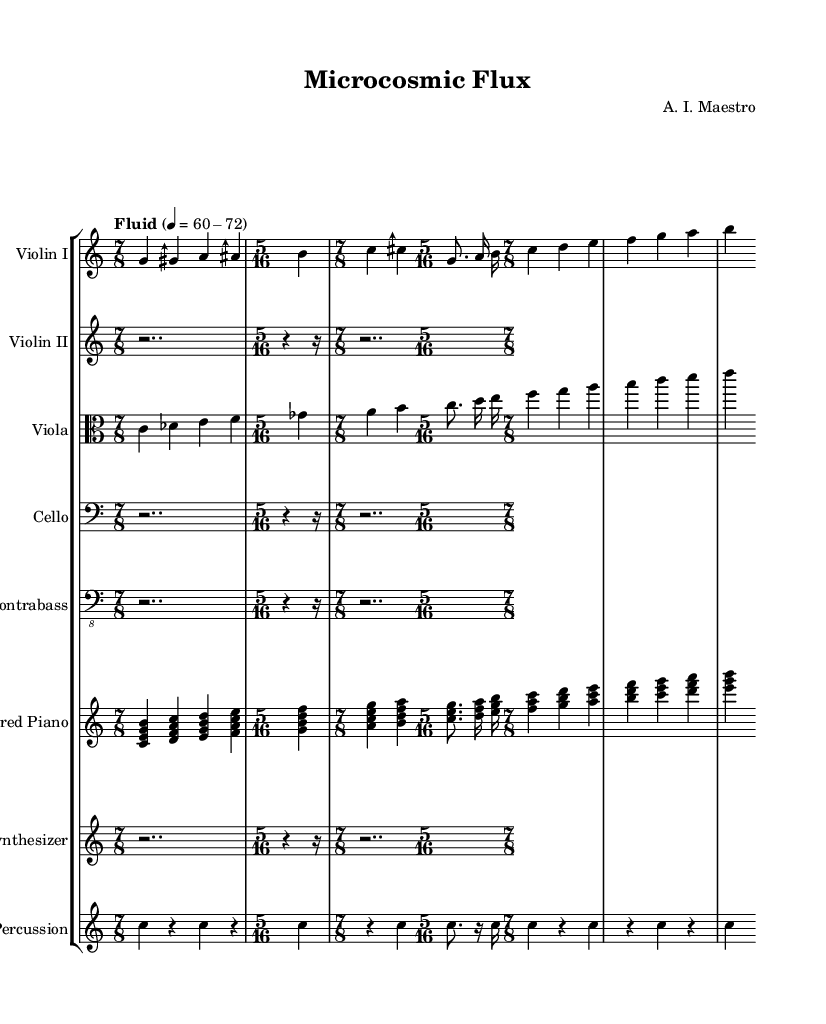What is the time signature of the piece? The predominant time signature is 7/8, which is indicated multiple times throughout the score. Additionally, there is a section with a 5/16 time signature.
Answer: 7/8 What is the tempo marking for the piece? The tempo marking is "Fluid," indicated at the start of the score, with a metronome marking of 60-72.
Answer: Fluid How many instruments are featured in this symphony? There are a total of 7 instruments listed in the score: Violin I, Violin II, Viola, Cello, Contrabass, Prepared Piano, Synthesizer, and Percussion.
Answer: 7 Which instrument plays the sustained rests in the 7/8 sections? The Violin II, Cello, Contrabass, and Synthesizer all play rests (notated as 'r') in the 7/8 sections, indicating a role of pause or support in the texture.
Answer: Violin II, Cello, Contrabass, Synthesizer What is the significance of using microtonal scales in this symphony? Microtonal scales allow for greater pitch variation, creating unique harmonic textures, contributing to the avant-garde character of the symphony, which encourages exploration beyond traditional western tuning; this is reflected in the sharp and flat notes used.
Answer: Greater pitch variation What rhythmic pattern is established by the percussion section? The percussion section establishes a consistent rhythmic motif that alternates between a repeated note on 'c' and rests, creating a driving pulse throughout the 7/8 sections.
Answer: Alternating 'c' and rests 